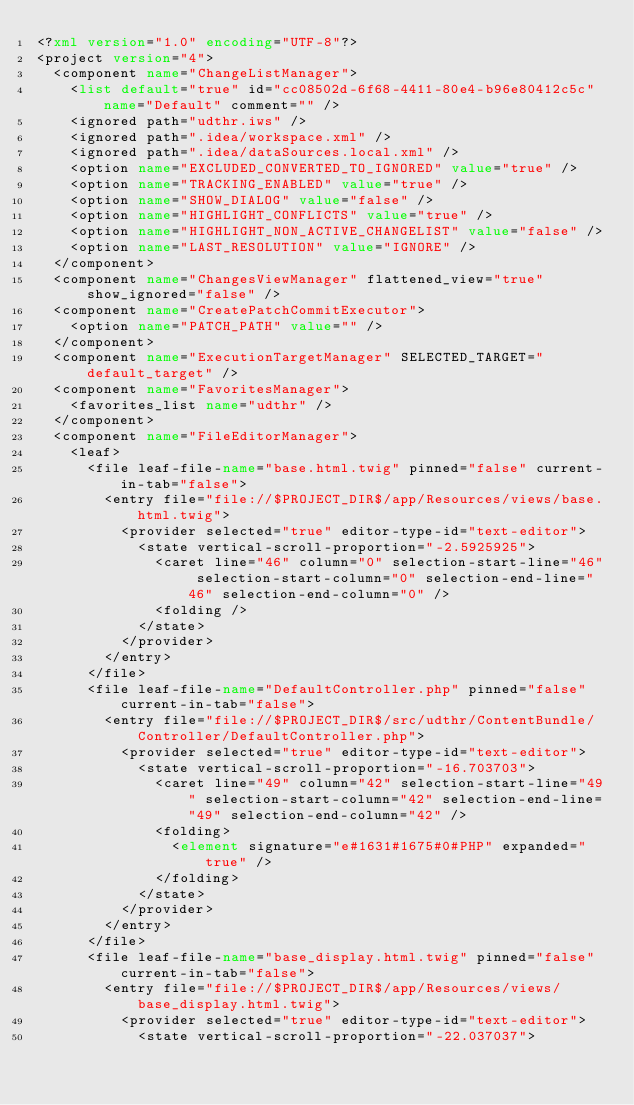<code> <loc_0><loc_0><loc_500><loc_500><_XML_><?xml version="1.0" encoding="UTF-8"?>
<project version="4">
  <component name="ChangeListManager">
    <list default="true" id="cc08502d-6f68-4411-80e4-b96e80412c5c" name="Default" comment="" />
    <ignored path="udthr.iws" />
    <ignored path=".idea/workspace.xml" />
    <ignored path=".idea/dataSources.local.xml" />
    <option name="EXCLUDED_CONVERTED_TO_IGNORED" value="true" />
    <option name="TRACKING_ENABLED" value="true" />
    <option name="SHOW_DIALOG" value="false" />
    <option name="HIGHLIGHT_CONFLICTS" value="true" />
    <option name="HIGHLIGHT_NON_ACTIVE_CHANGELIST" value="false" />
    <option name="LAST_RESOLUTION" value="IGNORE" />
  </component>
  <component name="ChangesViewManager" flattened_view="true" show_ignored="false" />
  <component name="CreatePatchCommitExecutor">
    <option name="PATCH_PATH" value="" />
  </component>
  <component name="ExecutionTargetManager" SELECTED_TARGET="default_target" />
  <component name="FavoritesManager">
    <favorites_list name="udthr" />
  </component>
  <component name="FileEditorManager">
    <leaf>
      <file leaf-file-name="base.html.twig" pinned="false" current-in-tab="false">
        <entry file="file://$PROJECT_DIR$/app/Resources/views/base.html.twig">
          <provider selected="true" editor-type-id="text-editor">
            <state vertical-scroll-proportion="-2.5925925">
              <caret line="46" column="0" selection-start-line="46" selection-start-column="0" selection-end-line="46" selection-end-column="0" />
              <folding />
            </state>
          </provider>
        </entry>
      </file>
      <file leaf-file-name="DefaultController.php" pinned="false" current-in-tab="false">
        <entry file="file://$PROJECT_DIR$/src/udthr/ContentBundle/Controller/DefaultController.php">
          <provider selected="true" editor-type-id="text-editor">
            <state vertical-scroll-proportion="-16.703703">
              <caret line="49" column="42" selection-start-line="49" selection-start-column="42" selection-end-line="49" selection-end-column="42" />
              <folding>
                <element signature="e#1631#1675#0#PHP" expanded="true" />
              </folding>
            </state>
          </provider>
        </entry>
      </file>
      <file leaf-file-name="base_display.html.twig" pinned="false" current-in-tab="false">
        <entry file="file://$PROJECT_DIR$/app/Resources/views/base_display.html.twig">
          <provider selected="true" editor-type-id="text-editor">
            <state vertical-scroll-proportion="-22.037037"></code> 